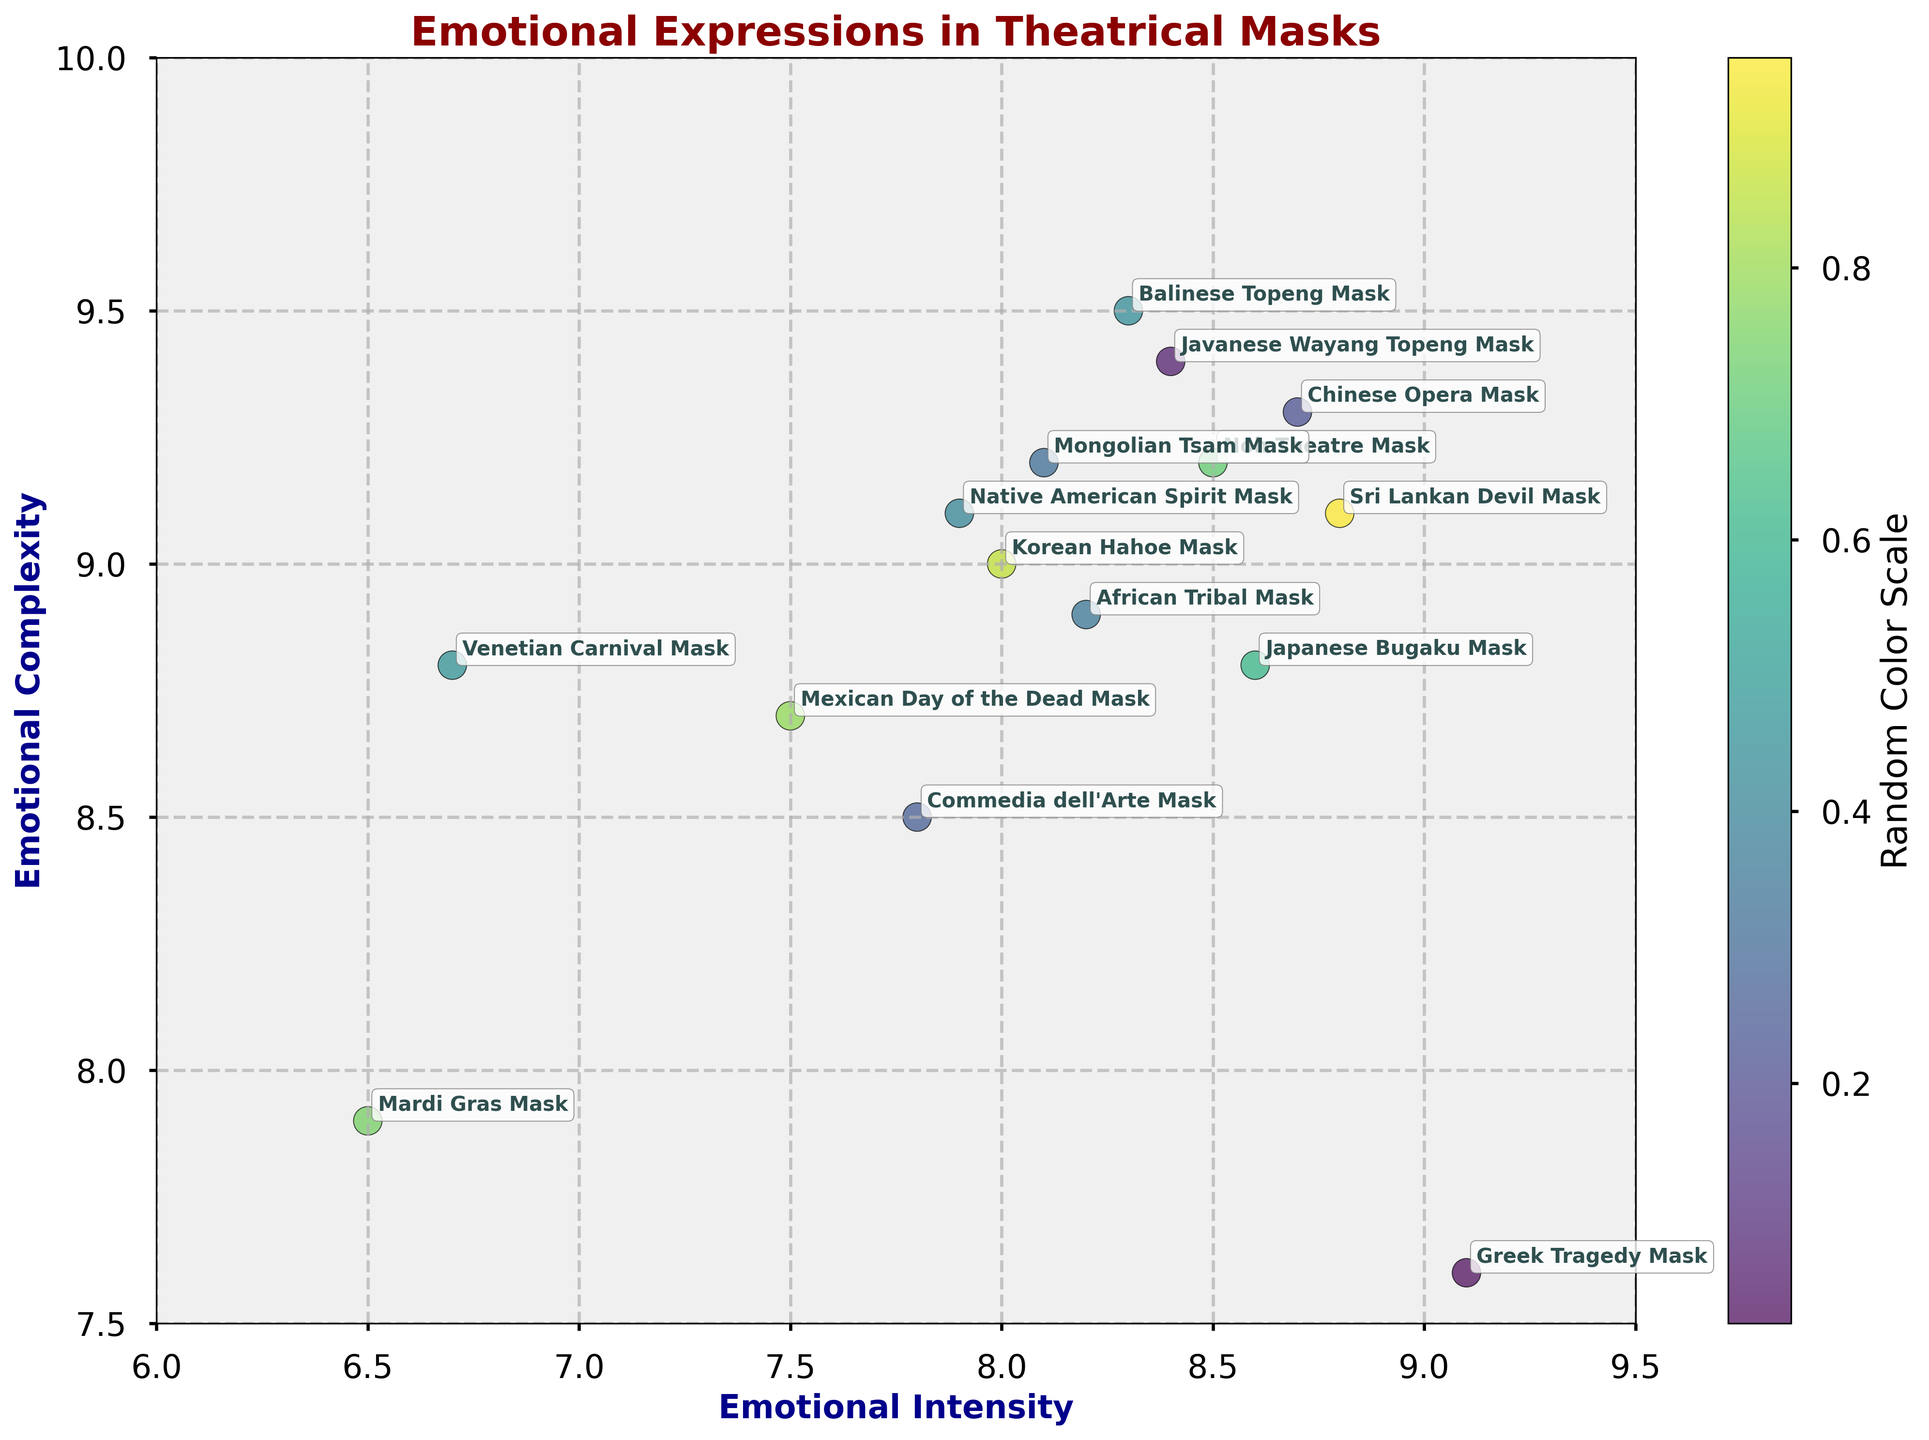What's the title of the chart? The title of the chart is located at the top of the figure and describes the content of the visualization.
Answer: Emotional Expressions in Theatrical Masks What's the range of the Emotional Intensity axis? The Emotional Intensity axis is labeled on the horizontal (x) axis. The range of this axis can be observed by looking at the minimum and maximum values.
Answer: 6 to 9.5 Which mask has the highest Emotional Complexity? To find the mask with the highest Emotional Complexity, look at the highest point on the vertical (y) axis and see which mask is labeled there.
Answer: Balinese Topeng Mask How many data points (masks) are represented in the plot? Count the number of points (scatter markers) plotted in the visualization. Each point represents one mask.
Answer: 15 Compare the Emotional Intensity of the Greek Tragedy Mask and the Venetian Carnival Mask. Which one is higher? Locate both the Greek Tragedy Mask and the Venetian Carnival Mask along the x-axis and compare their positions. The one farther to the right has a higher Emotional Intensity.
Answer: Greek Tragedy Mask What's the average Emotional Complexity of the Native American Spirit Mask and the Chinese Opera Mask? Find the y-values (Emotional Complexity) of both masks, sum them up and divide by 2 to find the average. Native American Spirit Mask: 9.1, Chinese Opera Mask: 9.3; (9.1 + 9.3) / 2 = 9.2.
Answer: 9.2 Which mask has approximately equal values of Emotional Intensity and Emotional Complexity? Look for the point where the x-value (Emotional Intensity) and y-value (Emotional Complexity) are approximately the same.
Answer: Greek Tragedy Mask What is the Emotional Intensity and Emotional Complexity of the Sri Lankan Devil Mask? Locate the Sri Lankan Devil Mask on the scatter plot and read its coordinates (x for Emotional Intensity, y for Emotional Complexity).
Answer: Emotional Intensity: 8.8, Emotional Complexity: 9.1 Which mask shows the lowest Emotional Intensity among all? Find the point on the x-axis that is the farthest to the left. That point represents the mask with the lowest Emotional Intensity.
Answer: Mardi Gras Mask Which two masks have almost the same Emotional Complexity close to 9.0 but different Emotional Intensities? Identify masks clustering near the y-value of 9.0 and compare their x-values to find those with different Emotional Intensities. Look for proximity in y-values but noticeable difference in x-values.
Answer: Native American Spirit Mask and Korean Hahoe Mask 